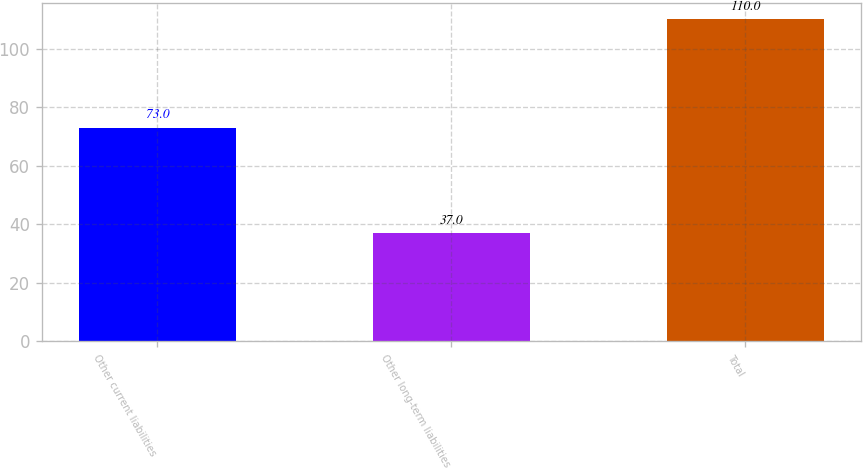Convert chart to OTSL. <chart><loc_0><loc_0><loc_500><loc_500><bar_chart><fcel>Other current liabilities<fcel>Other long-term liabilities<fcel>Total<nl><fcel>73<fcel>37<fcel>110<nl></chart> 